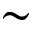<formula> <loc_0><loc_0><loc_500><loc_500>\sim</formula> 